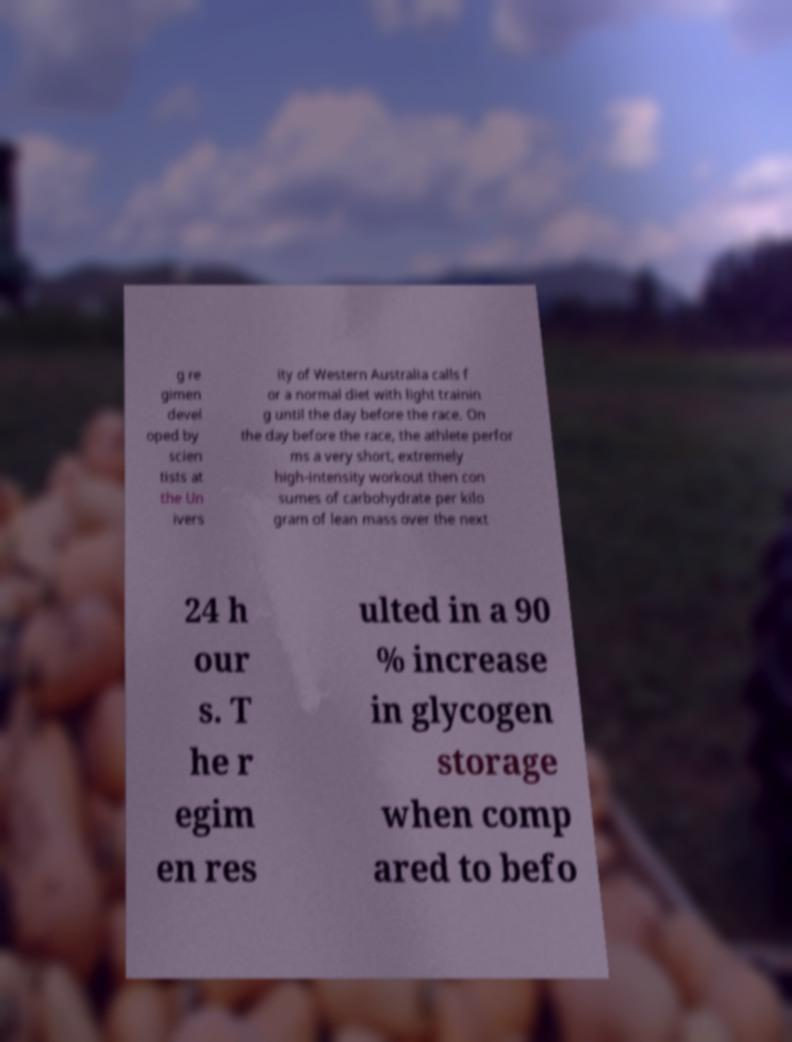Can you accurately transcribe the text from the provided image for me? g re gimen devel oped by scien tists at the Un ivers ity of Western Australia calls f or a normal diet with light trainin g until the day before the race. On the day before the race, the athlete perfor ms a very short, extremely high-intensity workout then con sumes of carbohydrate per kilo gram of lean mass over the next 24 h our s. T he r egim en res ulted in a 90 % increase in glycogen storage when comp ared to befo 